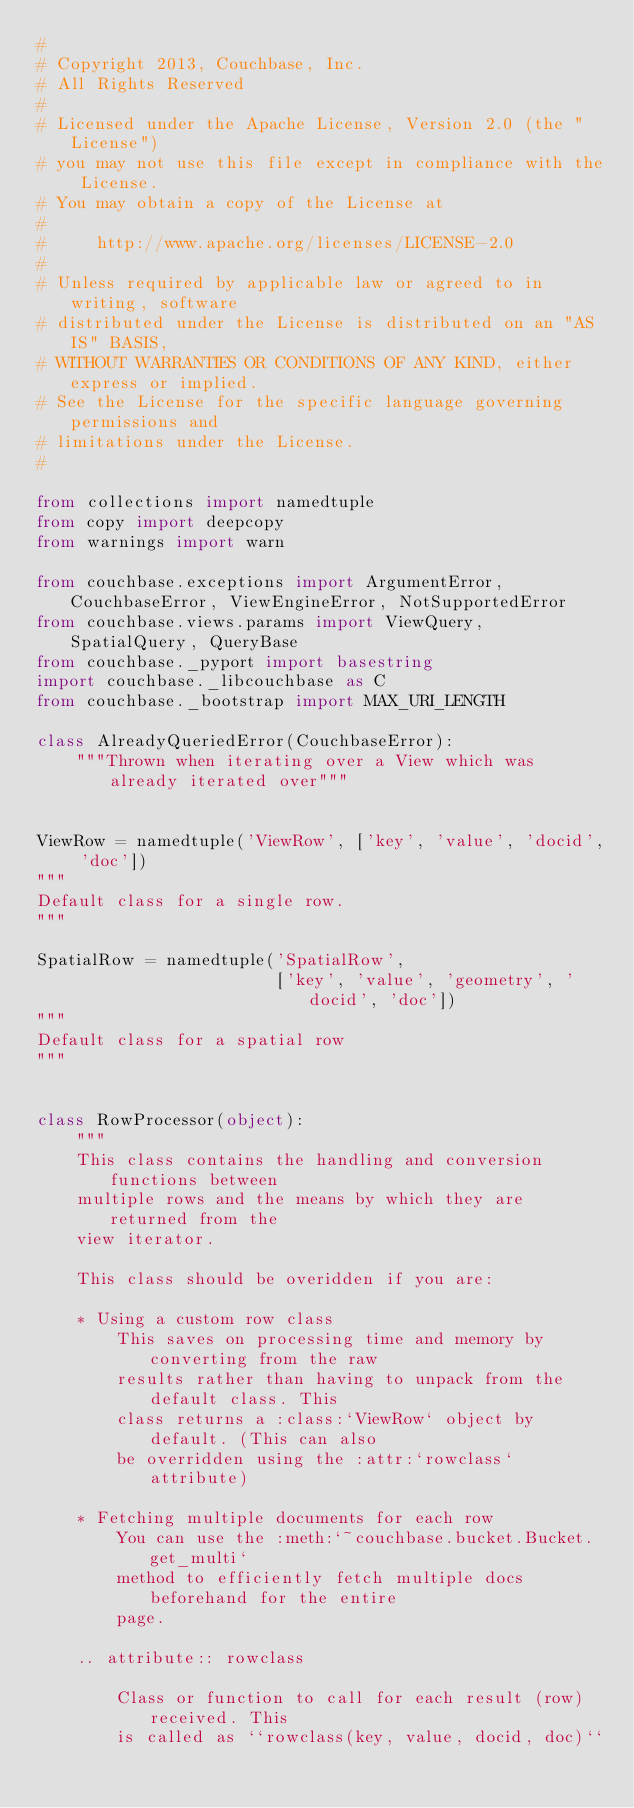<code> <loc_0><loc_0><loc_500><loc_500><_Python_>#
# Copyright 2013, Couchbase, Inc.
# All Rights Reserved
#
# Licensed under the Apache License, Version 2.0 (the "License")
# you may not use this file except in compliance with the License.
# You may obtain a copy of the License at
#
#     http://www.apache.org/licenses/LICENSE-2.0
#
# Unless required by applicable law or agreed to in writing, software
# distributed under the License is distributed on an "AS IS" BASIS,
# WITHOUT WARRANTIES OR CONDITIONS OF ANY KIND, either express or implied.
# See the License for the specific language governing permissions and
# limitations under the License.
#

from collections import namedtuple
from copy import deepcopy
from warnings import warn

from couchbase.exceptions import ArgumentError, CouchbaseError, ViewEngineError, NotSupportedError
from couchbase.views.params import ViewQuery, SpatialQuery, QueryBase
from couchbase._pyport import basestring
import couchbase._libcouchbase as C
from couchbase._bootstrap import MAX_URI_LENGTH

class AlreadyQueriedError(CouchbaseError):
    """Thrown when iterating over a View which was already iterated over"""


ViewRow = namedtuple('ViewRow', ['key', 'value', 'docid', 'doc'])
"""
Default class for a single row.
"""

SpatialRow = namedtuple('SpatialRow',
                        ['key', 'value', 'geometry', 'docid', 'doc'])
"""
Default class for a spatial row
"""


class RowProcessor(object):
    """
    This class contains the handling and conversion functions between
    multiple rows and the means by which they are returned from the
    view iterator.

    This class should be overidden if you are:

    * Using a custom row class
        This saves on processing time and memory by converting from the raw
        results rather than having to unpack from the default class. This
        class returns a :class:`ViewRow` object by default. (This can also
        be overridden using the :attr:`rowclass` attribute)

    * Fetching multiple documents for each row
        You can use the :meth:`~couchbase.bucket.Bucket.get_multi`
        method to efficiently fetch multiple docs beforehand for the entire
        page.

    .. attribute:: rowclass

        Class or function to call for each result (row) received. This
        is called as ``rowclass(key, value, docid, doc)``
</code> 